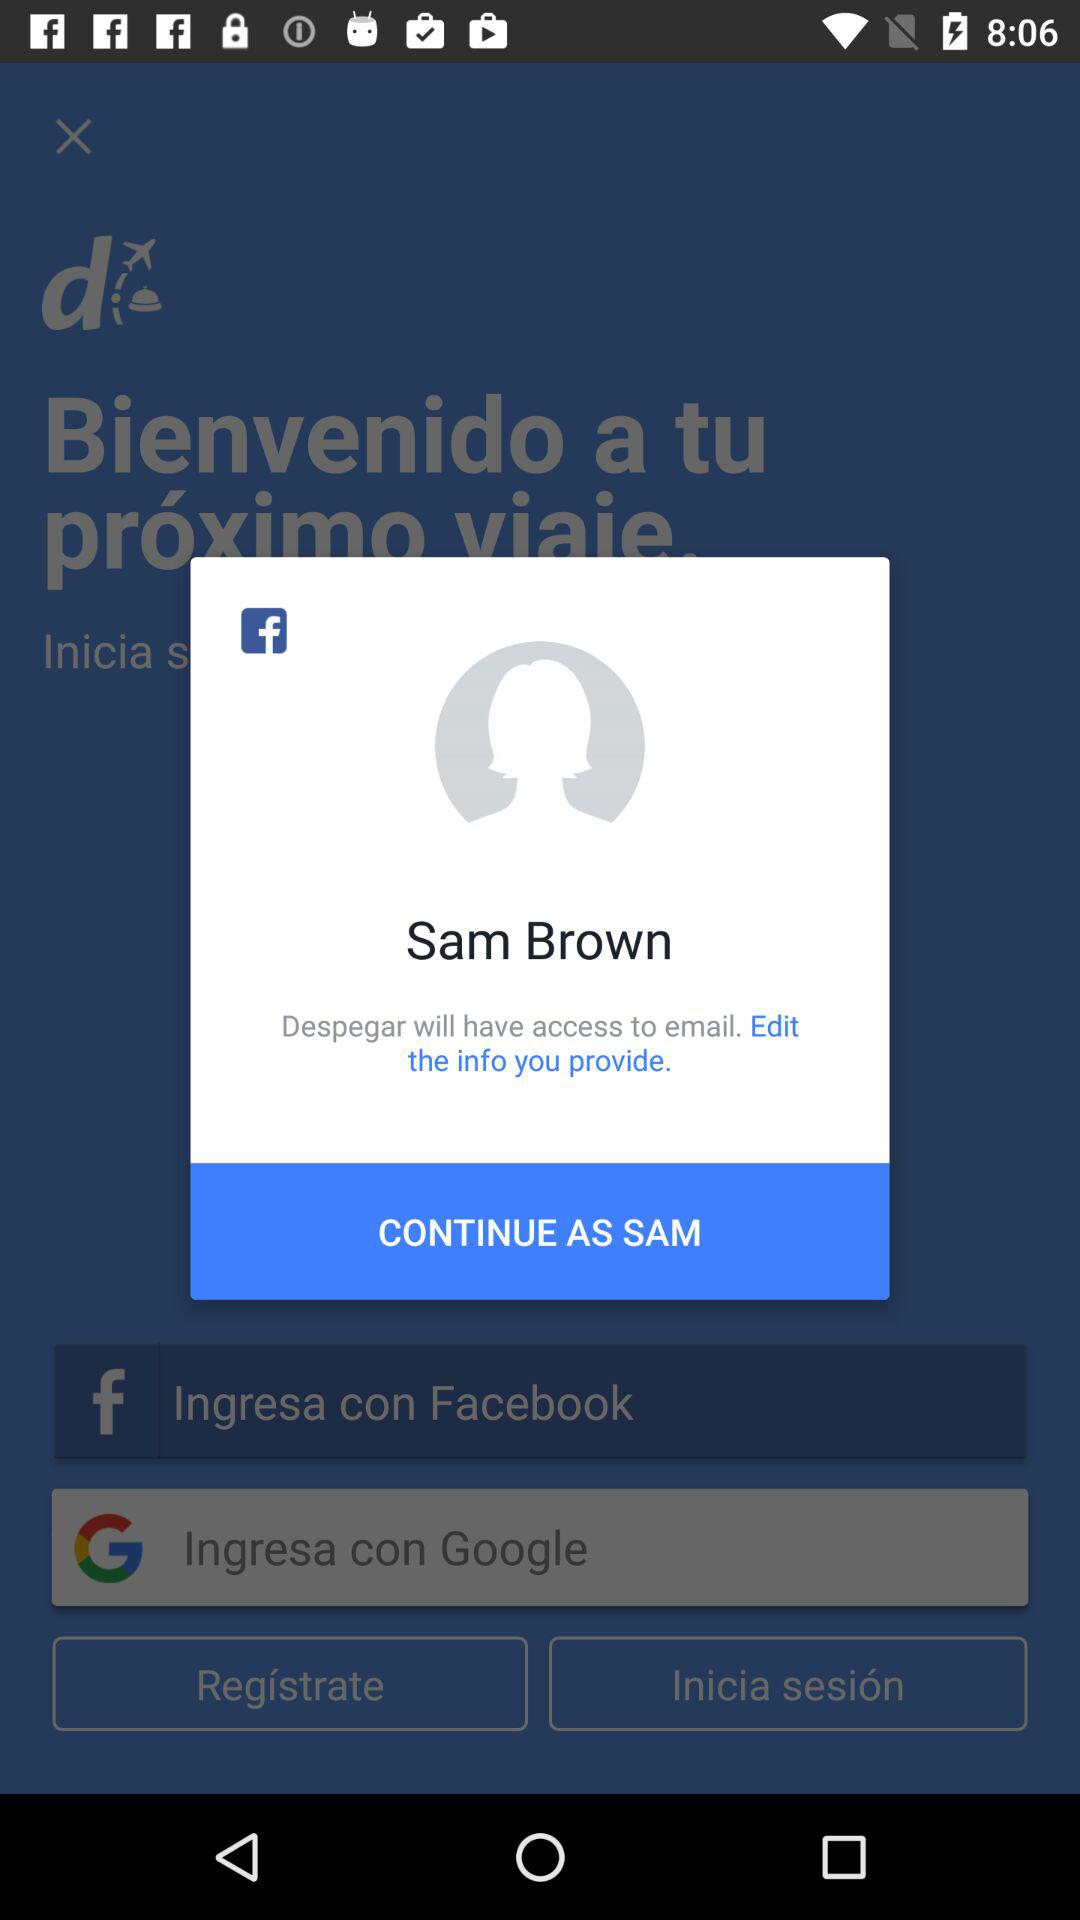What application will have access to email? The application is "Despegar". 